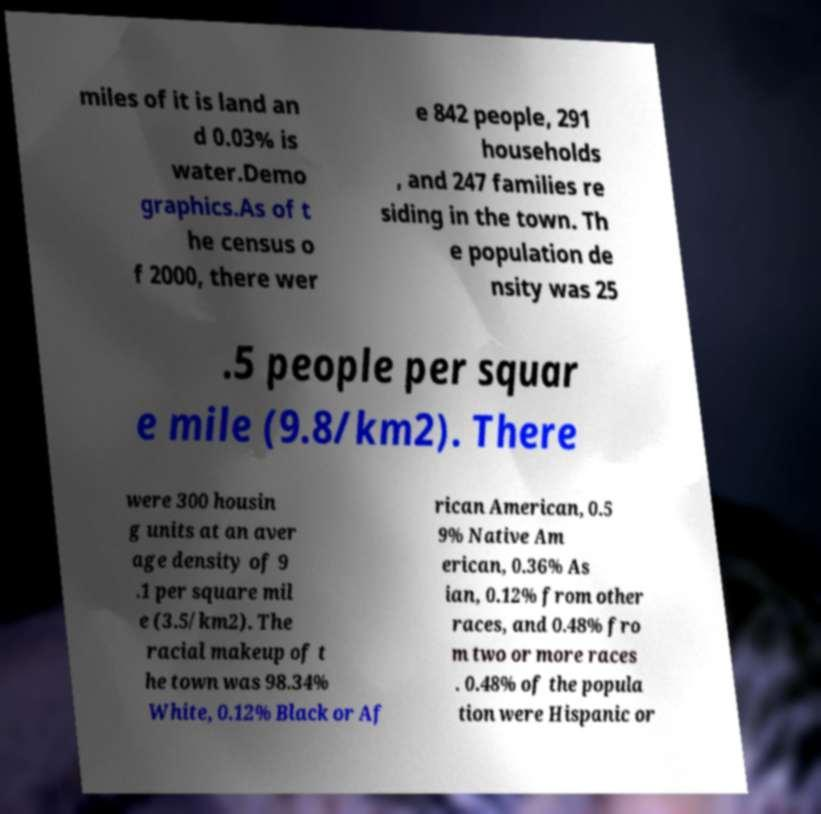Could you assist in decoding the text presented in this image and type it out clearly? miles of it is land an d 0.03% is water.Demo graphics.As of t he census o f 2000, there wer e 842 people, 291 households , and 247 families re siding in the town. Th e population de nsity was 25 .5 people per squar e mile (9.8/km2). There were 300 housin g units at an aver age density of 9 .1 per square mil e (3.5/km2). The racial makeup of t he town was 98.34% White, 0.12% Black or Af rican American, 0.5 9% Native Am erican, 0.36% As ian, 0.12% from other races, and 0.48% fro m two or more races . 0.48% of the popula tion were Hispanic or 